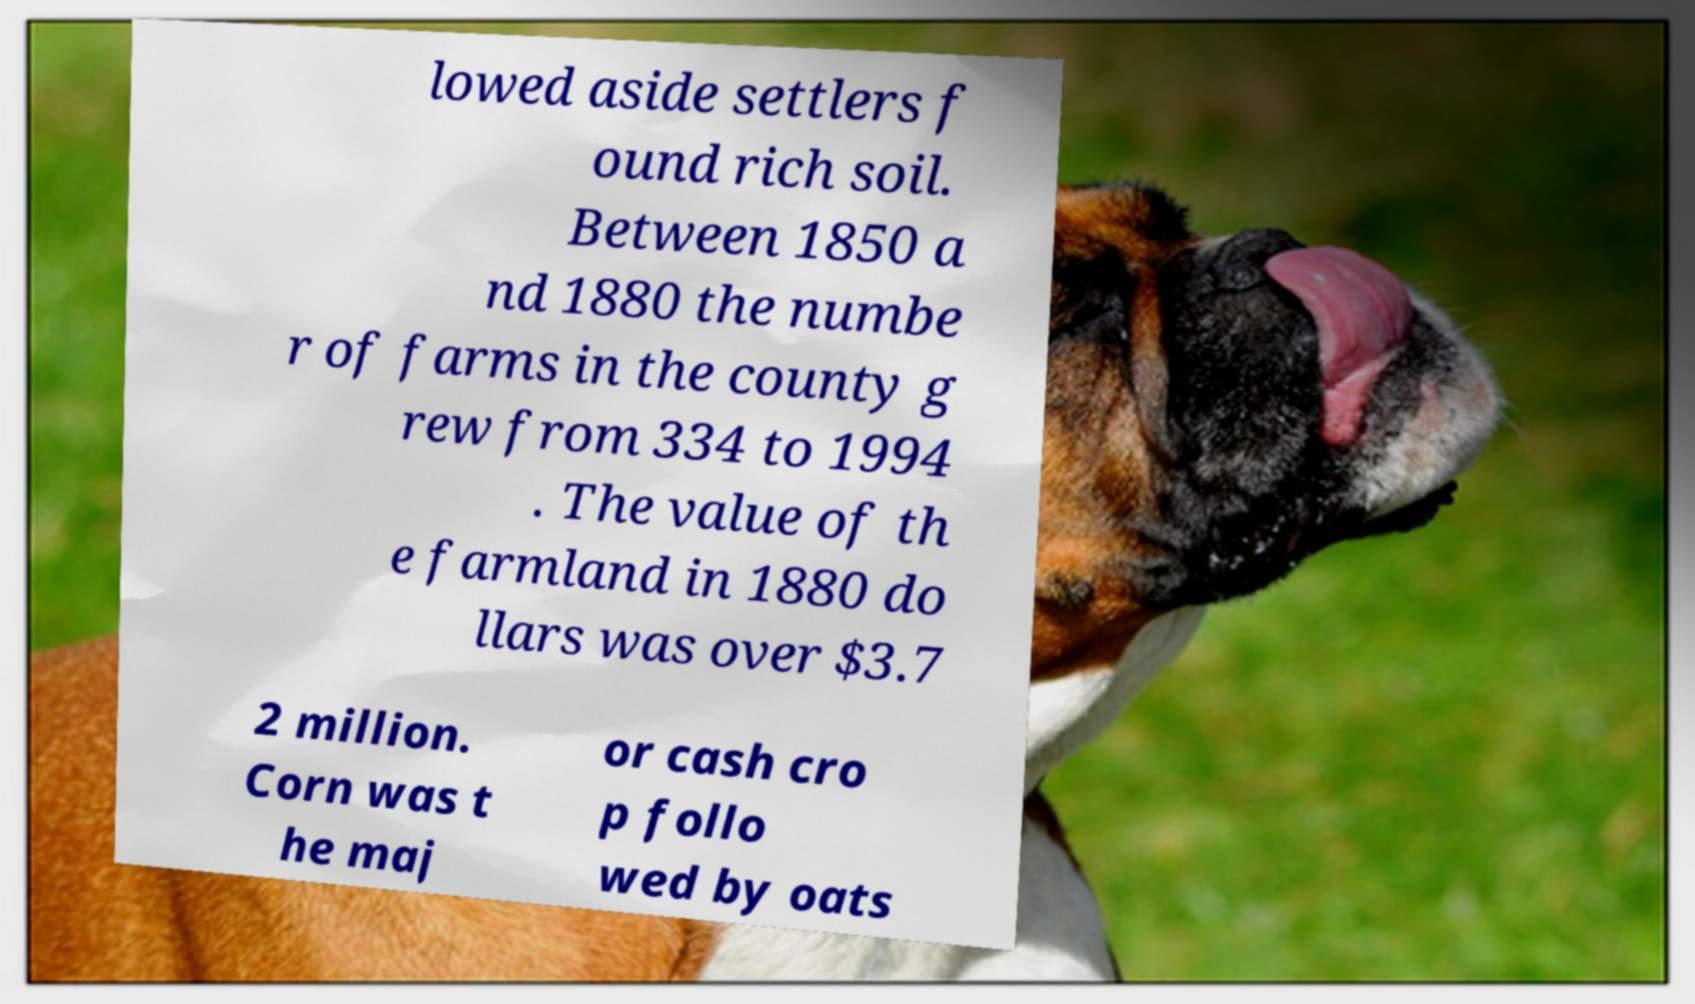Please read and relay the text visible in this image. What does it say? lowed aside settlers f ound rich soil. Between 1850 a nd 1880 the numbe r of farms in the county g rew from 334 to 1994 . The value of th e farmland in 1880 do llars was over $3.7 2 million. Corn was t he maj or cash cro p follo wed by oats 